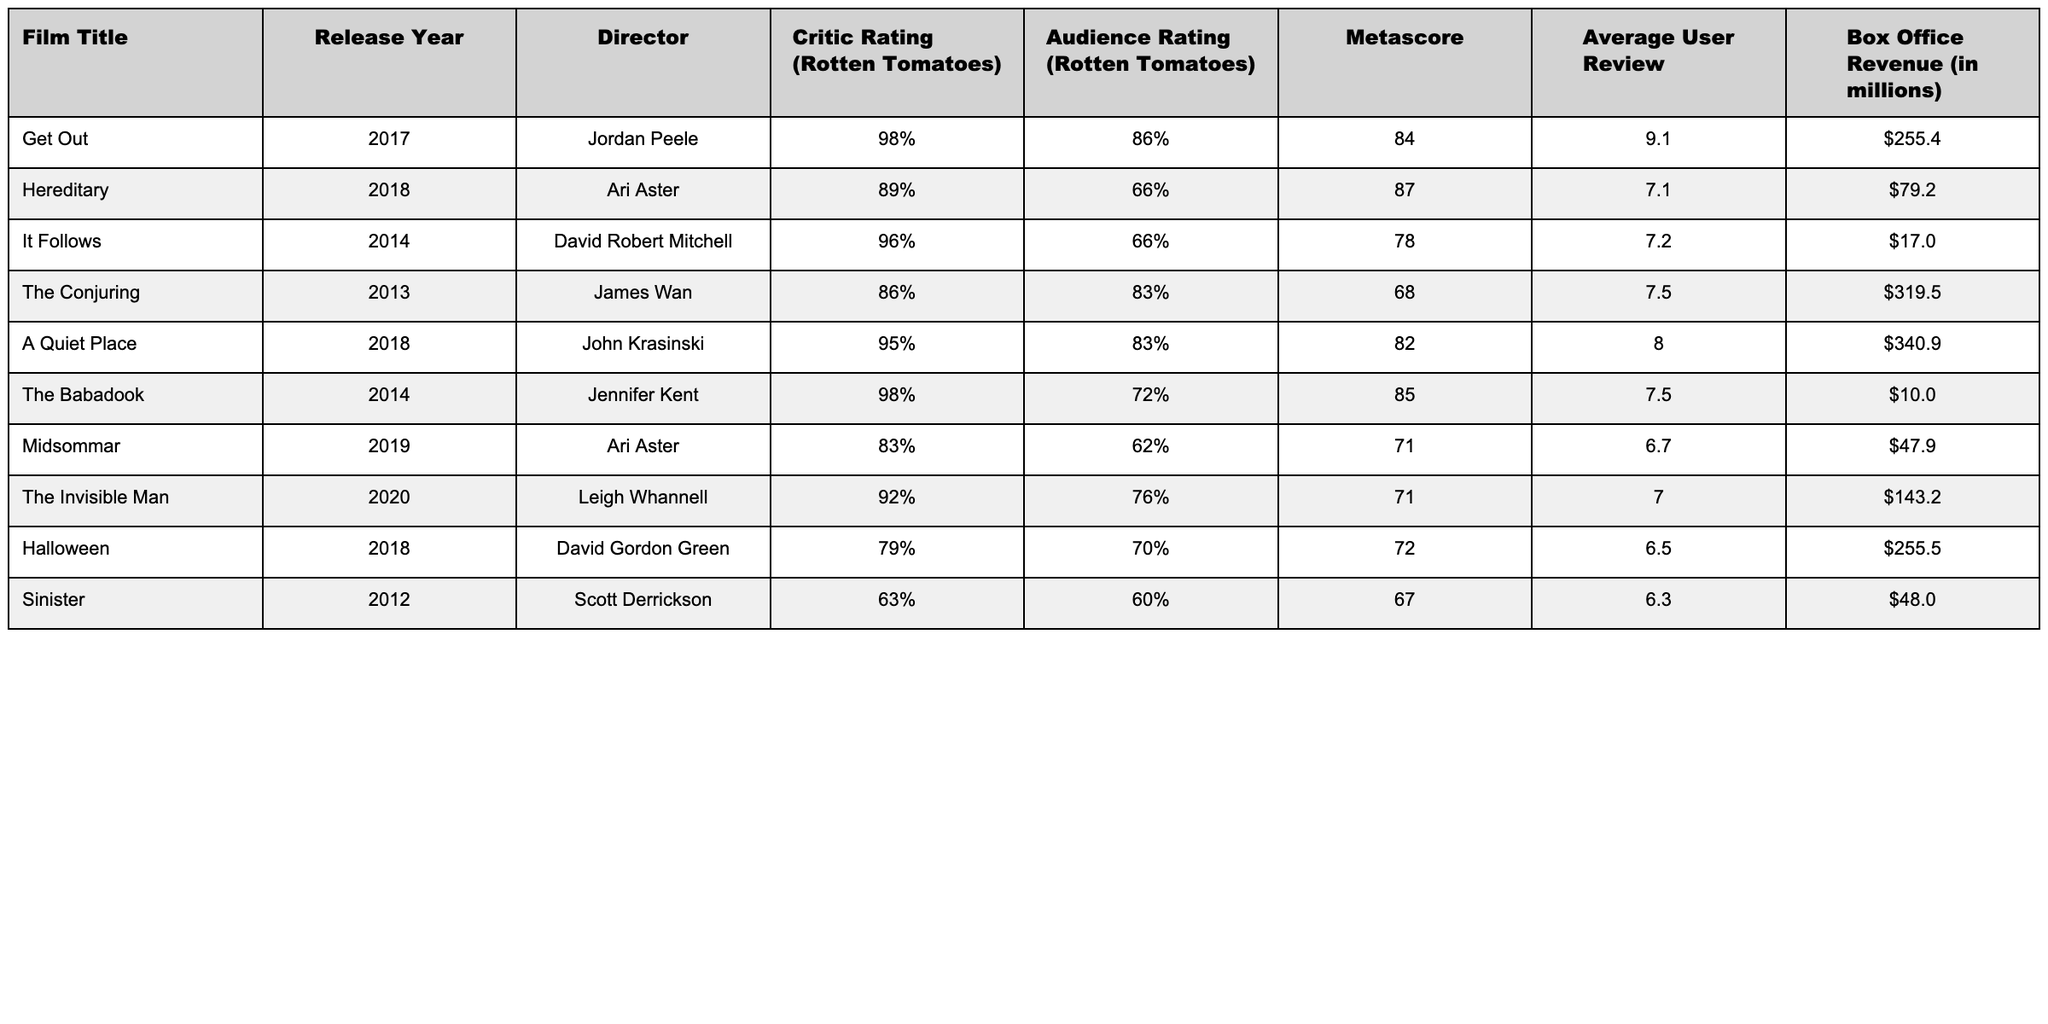What is the highest critic rating of a horror film in the table? The highest critic rating is provided for "Get Out" at 98%.
Answer: 98% Which film has the lowest audience rating? The film with the lowest audience rating is "Hereditary" at 66%.
Answer: 66% What is the average box office revenue of the films listed? Total box office revenue is $1,295.3 million from 10 films, so the average is $1,295.3 million / 10 = $129.53 million.
Answer: $129.53 million Which director has the highest average critic rating for their films in the table? "Jordan Peele" directed "Get Out" with a rating of 98%, which is the highest for a single film, while "Ari Aster" has two films with ratings of 89% and 83%. The average for Ari Aster is (89 + 83) / 2 = 86%. Therefore, Jordan Peele has the highest rating.
Answer: Jordan Peele Is there any film with a critic rating above 90% that made less than $100 million at the box office? "The Babadook" has a critic rating of 98% and earned $10 million at the box office, fitting both criteria.
Answer: Yes What is the difference in critic rating between the highest and the lowest-rated films? The highest-rated film "Get Out" has a critic rating of 98%, and the lowest-rated film "Sinister" has a critic rating of 63%. The difference is 98% - 63% = 35%.
Answer: 35% Do all films directed by Ari Aster have audience ratings below 70%? "Hereditary" has an audience rating of 66%, and "Midsommar" has an audience rating of 62%. Both ratings are below 70%, confirming that all his films listed meet this criterion.
Answer: Yes Which film achieved the highest box office revenue? "A Quiet Place" earned $340.9 million, which is more than any other film in the list.
Answer: $340.9 million What is the average user review rating of the films directed by James Wan? "The Conjuring" is the only film by James Wan in the table, so its average user review is 7.5.
Answer: 7.5 How many films in the table received a critic rating of 80% or more? There are 6 films with a critic rating of 80% or higher: "Get Out," "Hereditary," "It Follows," "The Conjuring," "A Quiet Place," and "The Babadook."
Answer: 6 